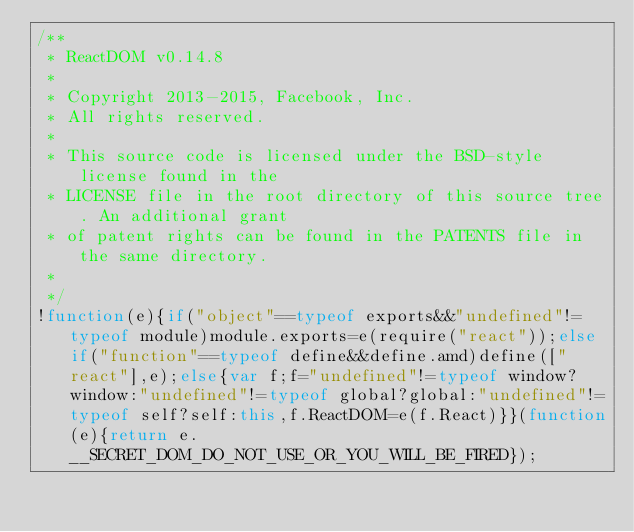<code> <loc_0><loc_0><loc_500><loc_500><_JavaScript_>/**
 * ReactDOM v0.14.8
 *
 * Copyright 2013-2015, Facebook, Inc.
 * All rights reserved.
 *
 * This source code is licensed under the BSD-style license found in the
 * LICENSE file in the root directory of this source tree. An additional grant
 * of patent rights can be found in the PATENTS file in the same directory.
 *
 */
!function(e){if("object"==typeof exports&&"undefined"!=typeof module)module.exports=e(require("react"));else if("function"==typeof define&&define.amd)define(["react"],e);else{var f;f="undefined"!=typeof window?window:"undefined"!=typeof global?global:"undefined"!=typeof self?self:this,f.ReactDOM=e(f.React)}}(function(e){return e.__SECRET_DOM_DO_NOT_USE_OR_YOU_WILL_BE_FIRED});</code> 